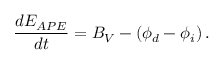Convert formula to latex. <formula><loc_0><loc_0><loc_500><loc_500>\frac { d E _ { A P E } } { d t } = B _ { V } - \left ( \phi _ { d } - \phi _ { i } \right ) .</formula> 